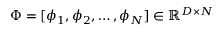<formula> <loc_0><loc_0><loc_500><loc_500>\Phi = [ \phi _ { 1 } , \phi _ { 2 } , \dots , \phi _ { N } ] \in \mathbb { R } ^ { D \times N }</formula> 